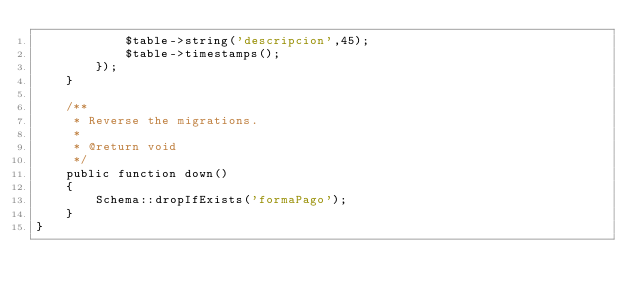<code> <loc_0><loc_0><loc_500><loc_500><_PHP_>            $table->string('descripcion',45);
            $table->timestamps();
        });
    }

    /**
     * Reverse the migrations.
     *
     * @return void
     */
    public function down()
    {
        Schema::dropIfExists('formaPago');
    }
}
</code> 